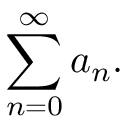<formula> <loc_0><loc_0><loc_500><loc_500>\sum _ { n = 0 } ^ { \infty } a _ { n } .</formula> 